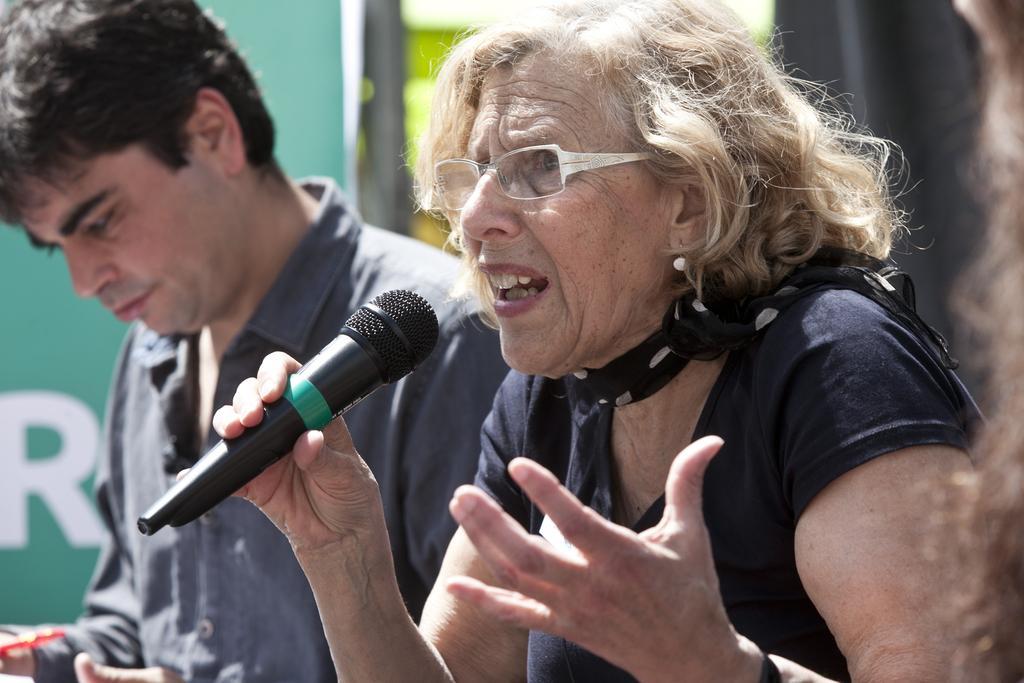In one or two sentences, can you explain what this image depicts? There is a woman holding a microphone in her right hand and she is speaking. There is a man who is on the left side. 